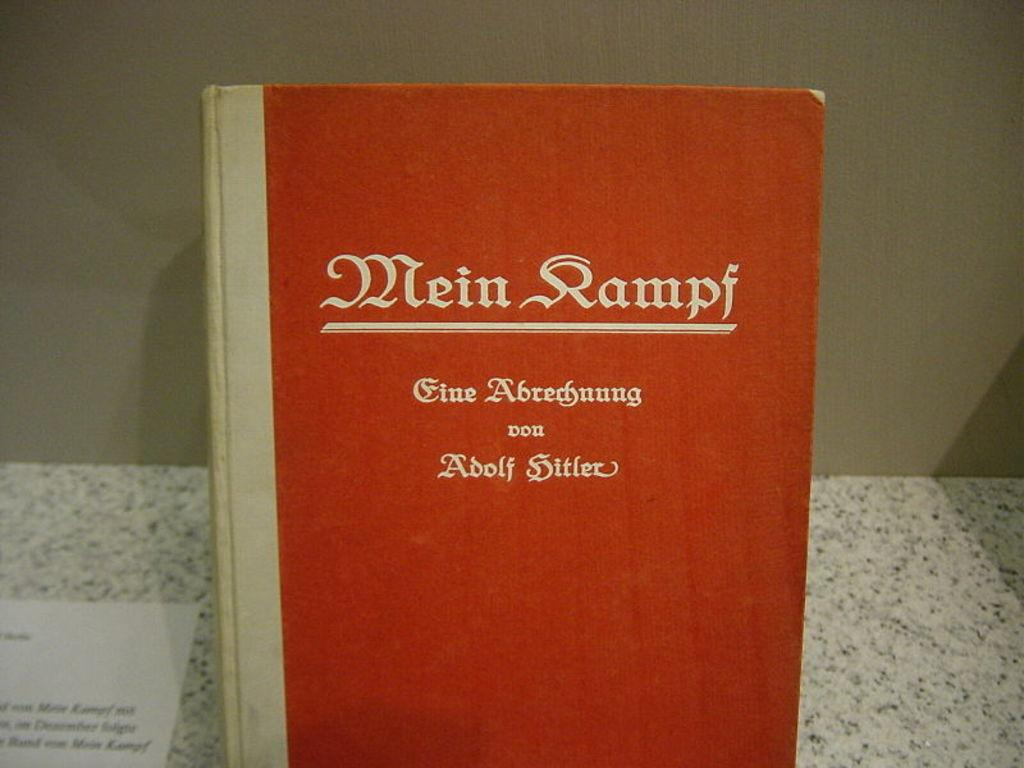Provide a one-sentence caption for the provided image. a close up of the book Mein Kampf with other german text. 